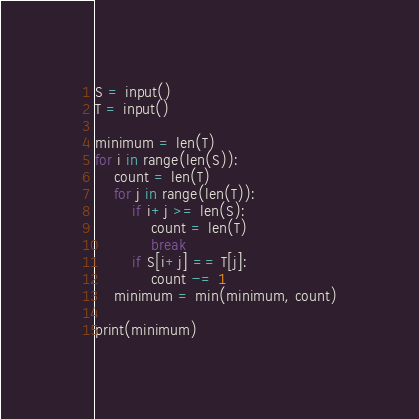<code> <loc_0><loc_0><loc_500><loc_500><_Python_>S = input()
T = input()

minimum = len(T)
for i in range(len(S)):
    count = len(T)
    for j in range(len(T)):
        if i+j >= len(S):
            count = len(T)
            break
        if S[i+j] == T[j]:
            count -= 1
    minimum = min(minimum, count)

print(minimum)</code> 